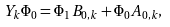Convert formula to latex. <formula><loc_0><loc_0><loc_500><loc_500>Y _ { k } \Phi _ { 0 } = \Phi _ { 1 } B _ { 0 , k } + \Phi _ { 0 } A _ { 0 , k } ,</formula> 